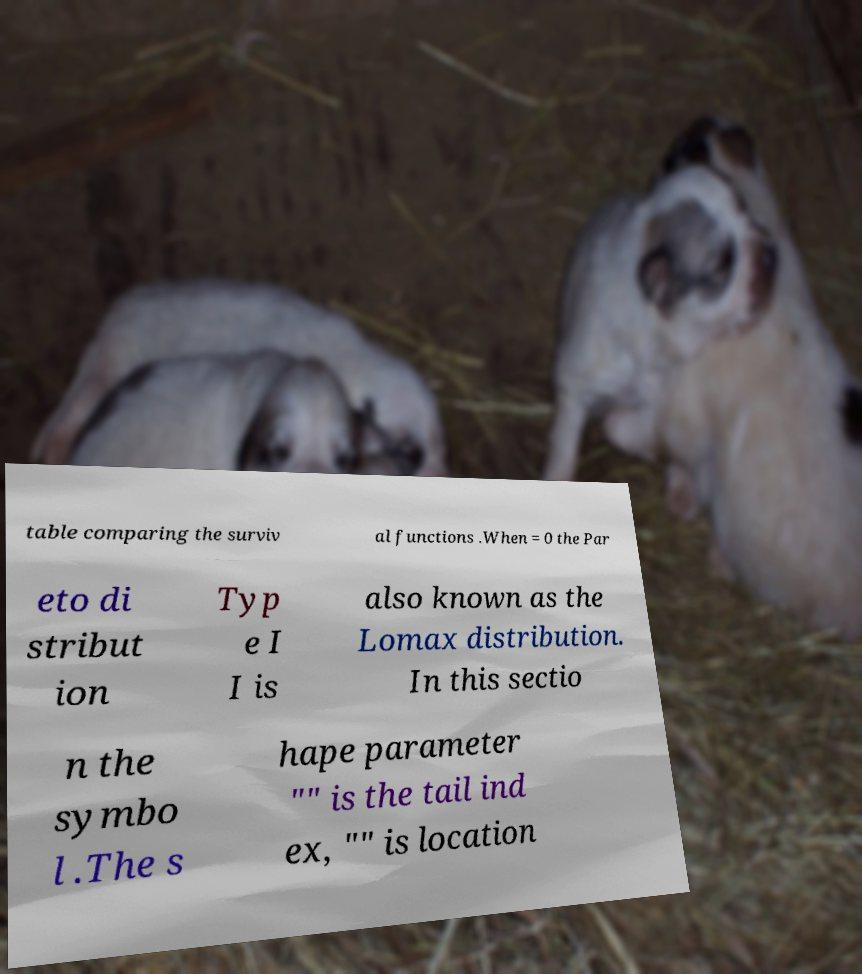Could you assist in decoding the text presented in this image and type it out clearly? table comparing the surviv al functions .When = 0 the Par eto di stribut ion Typ e I I is also known as the Lomax distribution. In this sectio n the symbo l .The s hape parameter "" is the tail ind ex, "" is location 